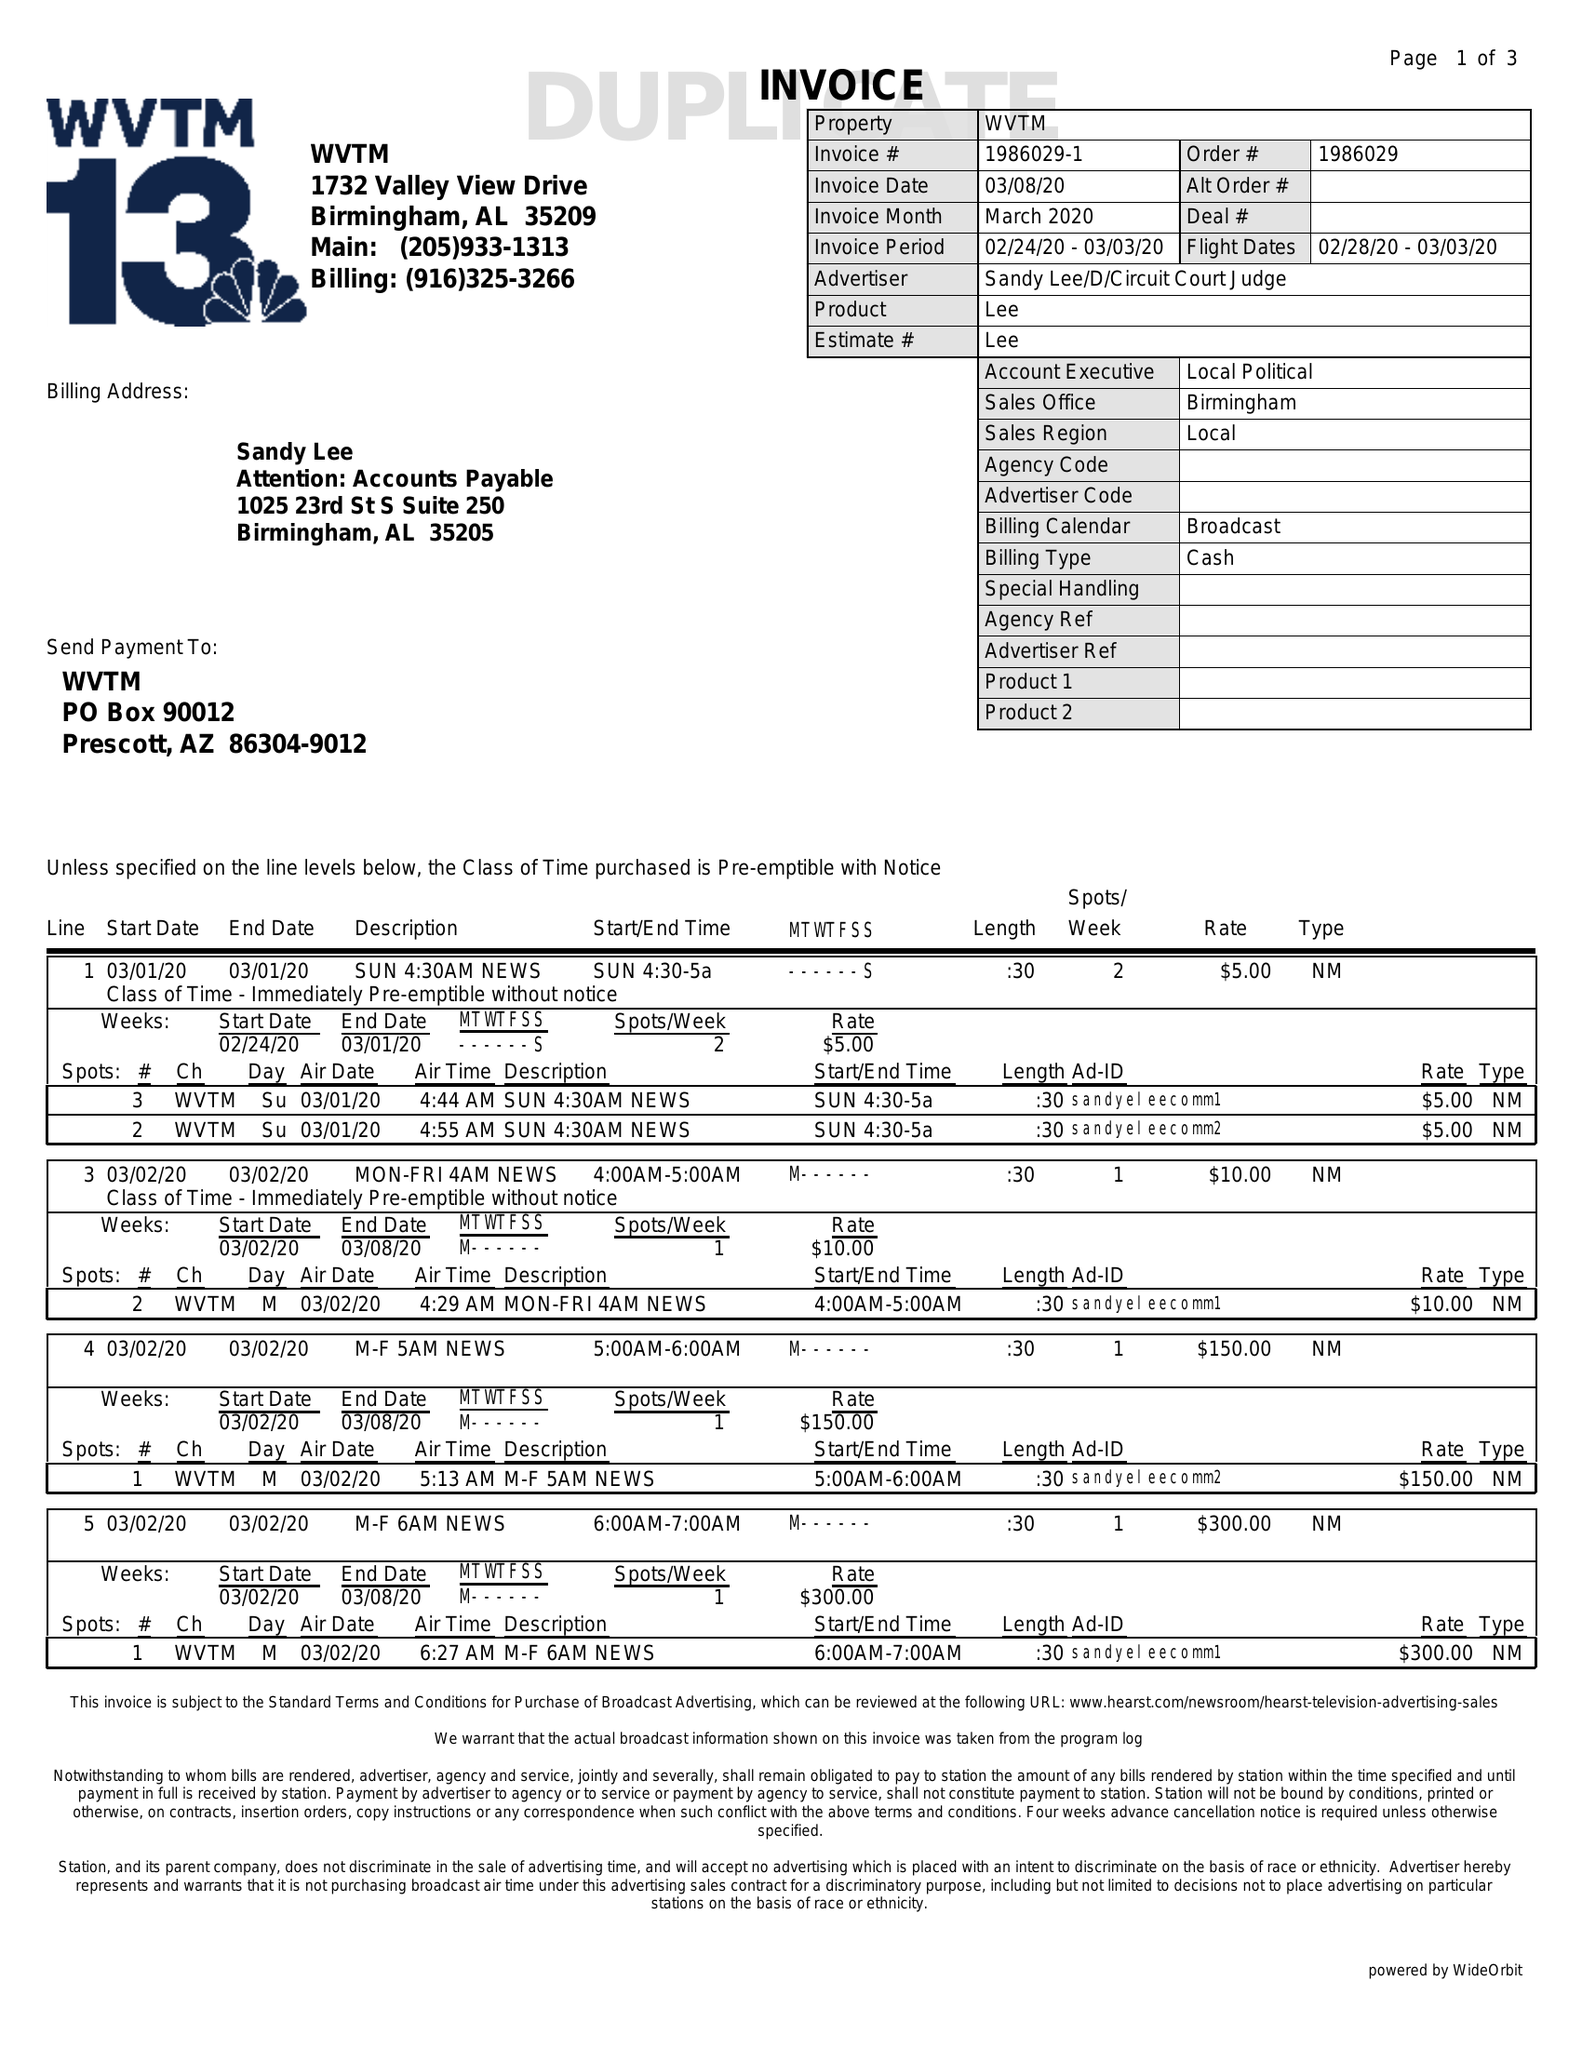What is the value for the gross_amount?
Answer the question using a single word or phrase. 2255.00 